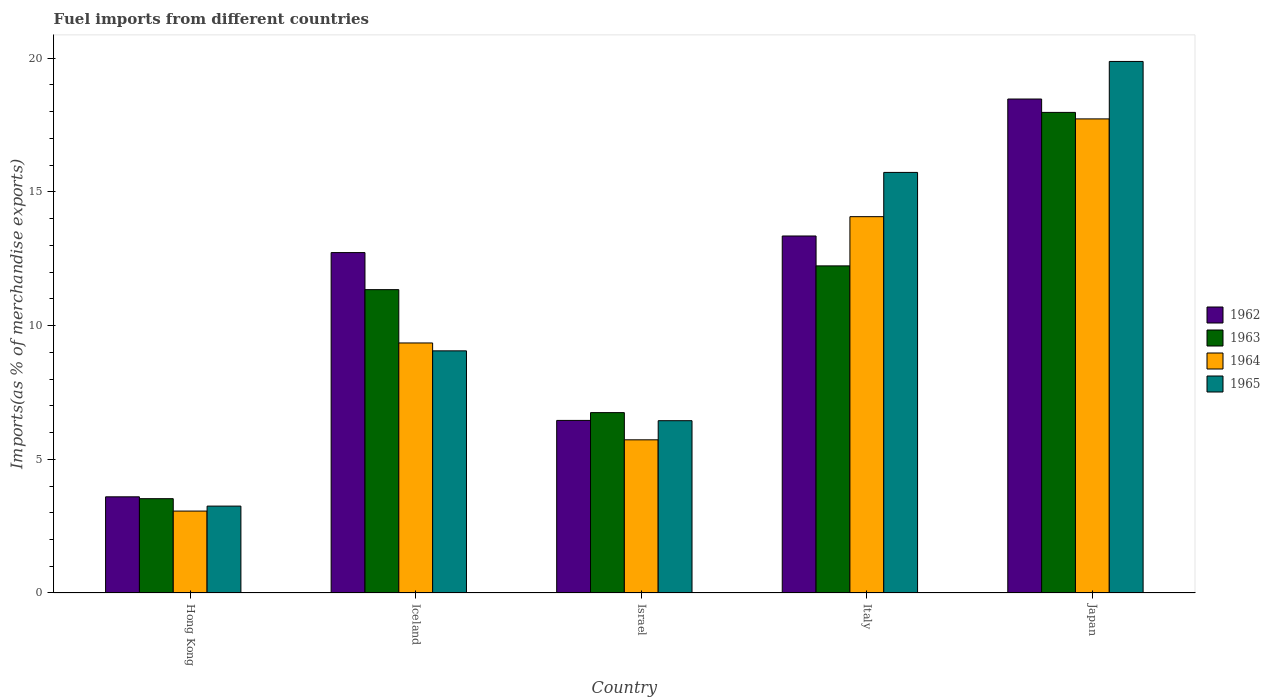How many different coloured bars are there?
Offer a very short reply. 4. How many bars are there on the 2nd tick from the left?
Provide a short and direct response. 4. How many bars are there on the 4th tick from the right?
Offer a terse response. 4. What is the label of the 1st group of bars from the left?
Make the answer very short. Hong Kong. In how many cases, is the number of bars for a given country not equal to the number of legend labels?
Provide a succinct answer. 0. What is the percentage of imports to different countries in 1963 in Japan?
Make the answer very short. 17.97. Across all countries, what is the maximum percentage of imports to different countries in 1964?
Your response must be concise. 17.73. Across all countries, what is the minimum percentage of imports to different countries in 1962?
Offer a terse response. 3.6. In which country was the percentage of imports to different countries in 1962 maximum?
Ensure brevity in your answer.  Japan. In which country was the percentage of imports to different countries in 1964 minimum?
Keep it short and to the point. Hong Kong. What is the total percentage of imports to different countries in 1963 in the graph?
Offer a very short reply. 51.83. What is the difference between the percentage of imports to different countries in 1964 in Hong Kong and that in Iceland?
Make the answer very short. -6.29. What is the difference between the percentage of imports to different countries in 1962 in Israel and the percentage of imports to different countries in 1965 in Hong Kong?
Keep it short and to the point. 3.2. What is the average percentage of imports to different countries in 1963 per country?
Keep it short and to the point. 10.37. What is the difference between the percentage of imports to different countries of/in 1965 and percentage of imports to different countries of/in 1962 in Japan?
Make the answer very short. 1.41. In how many countries, is the percentage of imports to different countries in 1964 greater than 8 %?
Provide a succinct answer. 3. What is the ratio of the percentage of imports to different countries in 1963 in Iceland to that in Japan?
Ensure brevity in your answer.  0.63. Is the percentage of imports to different countries in 1965 in Iceland less than that in Japan?
Keep it short and to the point. Yes. Is the difference between the percentage of imports to different countries in 1965 in Israel and Japan greater than the difference between the percentage of imports to different countries in 1962 in Israel and Japan?
Offer a very short reply. No. What is the difference between the highest and the second highest percentage of imports to different countries in 1965?
Your answer should be compact. -10.82. What is the difference between the highest and the lowest percentage of imports to different countries in 1962?
Your answer should be very brief. 14.88. Is it the case that in every country, the sum of the percentage of imports to different countries in 1965 and percentage of imports to different countries in 1963 is greater than the sum of percentage of imports to different countries in 1962 and percentage of imports to different countries in 1964?
Keep it short and to the point. No. What does the 3rd bar from the left in Italy represents?
Provide a succinct answer. 1964. What does the 2nd bar from the right in Hong Kong represents?
Ensure brevity in your answer.  1964. Is it the case that in every country, the sum of the percentage of imports to different countries in 1964 and percentage of imports to different countries in 1963 is greater than the percentage of imports to different countries in 1962?
Provide a short and direct response. Yes. How many bars are there?
Your answer should be very brief. 20. Are all the bars in the graph horizontal?
Offer a very short reply. No. How many countries are there in the graph?
Your answer should be very brief. 5. What is the difference between two consecutive major ticks on the Y-axis?
Give a very brief answer. 5. Does the graph contain any zero values?
Offer a terse response. No. Does the graph contain grids?
Offer a very short reply. No. How many legend labels are there?
Make the answer very short. 4. How are the legend labels stacked?
Provide a succinct answer. Vertical. What is the title of the graph?
Provide a succinct answer. Fuel imports from different countries. What is the label or title of the Y-axis?
Give a very brief answer. Imports(as % of merchandise exports). What is the Imports(as % of merchandise exports) of 1962 in Hong Kong?
Your answer should be compact. 3.6. What is the Imports(as % of merchandise exports) in 1963 in Hong Kong?
Ensure brevity in your answer.  3.53. What is the Imports(as % of merchandise exports) in 1964 in Hong Kong?
Your answer should be compact. 3.06. What is the Imports(as % of merchandise exports) in 1965 in Hong Kong?
Your response must be concise. 3.25. What is the Imports(as % of merchandise exports) in 1962 in Iceland?
Offer a very short reply. 12.73. What is the Imports(as % of merchandise exports) in 1963 in Iceland?
Offer a very short reply. 11.35. What is the Imports(as % of merchandise exports) in 1964 in Iceland?
Provide a succinct answer. 9.35. What is the Imports(as % of merchandise exports) of 1965 in Iceland?
Your response must be concise. 9.06. What is the Imports(as % of merchandise exports) of 1962 in Israel?
Your response must be concise. 6.45. What is the Imports(as % of merchandise exports) of 1963 in Israel?
Give a very brief answer. 6.75. What is the Imports(as % of merchandise exports) in 1964 in Israel?
Make the answer very short. 5.73. What is the Imports(as % of merchandise exports) in 1965 in Israel?
Your response must be concise. 6.44. What is the Imports(as % of merchandise exports) in 1962 in Italy?
Your answer should be compact. 13.35. What is the Imports(as % of merchandise exports) of 1963 in Italy?
Your answer should be compact. 12.23. What is the Imports(as % of merchandise exports) in 1964 in Italy?
Give a very brief answer. 14.07. What is the Imports(as % of merchandise exports) in 1965 in Italy?
Provide a short and direct response. 15.73. What is the Imports(as % of merchandise exports) of 1962 in Japan?
Keep it short and to the point. 18.47. What is the Imports(as % of merchandise exports) in 1963 in Japan?
Make the answer very short. 17.97. What is the Imports(as % of merchandise exports) of 1964 in Japan?
Ensure brevity in your answer.  17.73. What is the Imports(as % of merchandise exports) in 1965 in Japan?
Make the answer very short. 19.88. Across all countries, what is the maximum Imports(as % of merchandise exports) of 1962?
Ensure brevity in your answer.  18.47. Across all countries, what is the maximum Imports(as % of merchandise exports) of 1963?
Ensure brevity in your answer.  17.97. Across all countries, what is the maximum Imports(as % of merchandise exports) in 1964?
Ensure brevity in your answer.  17.73. Across all countries, what is the maximum Imports(as % of merchandise exports) in 1965?
Your answer should be compact. 19.88. Across all countries, what is the minimum Imports(as % of merchandise exports) of 1962?
Your response must be concise. 3.6. Across all countries, what is the minimum Imports(as % of merchandise exports) of 1963?
Keep it short and to the point. 3.53. Across all countries, what is the minimum Imports(as % of merchandise exports) of 1964?
Offer a terse response. 3.06. Across all countries, what is the minimum Imports(as % of merchandise exports) in 1965?
Offer a very short reply. 3.25. What is the total Imports(as % of merchandise exports) in 1962 in the graph?
Offer a very short reply. 54.61. What is the total Imports(as % of merchandise exports) of 1963 in the graph?
Keep it short and to the point. 51.83. What is the total Imports(as % of merchandise exports) in 1964 in the graph?
Make the answer very short. 49.95. What is the total Imports(as % of merchandise exports) of 1965 in the graph?
Provide a short and direct response. 54.36. What is the difference between the Imports(as % of merchandise exports) of 1962 in Hong Kong and that in Iceland?
Offer a very short reply. -9.13. What is the difference between the Imports(as % of merchandise exports) of 1963 in Hong Kong and that in Iceland?
Provide a succinct answer. -7.82. What is the difference between the Imports(as % of merchandise exports) in 1964 in Hong Kong and that in Iceland?
Your answer should be compact. -6.29. What is the difference between the Imports(as % of merchandise exports) in 1965 in Hong Kong and that in Iceland?
Keep it short and to the point. -5.81. What is the difference between the Imports(as % of merchandise exports) of 1962 in Hong Kong and that in Israel?
Make the answer very short. -2.86. What is the difference between the Imports(as % of merchandise exports) in 1963 in Hong Kong and that in Israel?
Your answer should be very brief. -3.22. What is the difference between the Imports(as % of merchandise exports) of 1964 in Hong Kong and that in Israel?
Provide a short and direct response. -2.66. What is the difference between the Imports(as % of merchandise exports) of 1965 in Hong Kong and that in Israel?
Your response must be concise. -3.19. What is the difference between the Imports(as % of merchandise exports) of 1962 in Hong Kong and that in Italy?
Provide a succinct answer. -9.76. What is the difference between the Imports(as % of merchandise exports) in 1963 in Hong Kong and that in Italy?
Keep it short and to the point. -8.71. What is the difference between the Imports(as % of merchandise exports) of 1964 in Hong Kong and that in Italy?
Your response must be concise. -11.01. What is the difference between the Imports(as % of merchandise exports) in 1965 in Hong Kong and that in Italy?
Offer a very short reply. -12.48. What is the difference between the Imports(as % of merchandise exports) in 1962 in Hong Kong and that in Japan?
Offer a very short reply. -14.88. What is the difference between the Imports(as % of merchandise exports) in 1963 in Hong Kong and that in Japan?
Provide a succinct answer. -14.45. What is the difference between the Imports(as % of merchandise exports) in 1964 in Hong Kong and that in Japan?
Ensure brevity in your answer.  -14.67. What is the difference between the Imports(as % of merchandise exports) of 1965 in Hong Kong and that in Japan?
Provide a succinct answer. -16.63. What is the difference between the Imports(as % of merchandise exports) of 1962 in Iceland and that in Israel?
Your response must be concise. 6.28. What is the difference between the Imports(as % of merchandise exports) in 1963 in Iceland and that in Israel?
Your answer should be compact. 4.6. What is the difference between the Imports(as % of merchandise exports) in 1964 in Iceland and that in Israel?
Provide a succinct answer. 3.62. What is the difference between the Imports(as % of merchandise exports) of 1965 in Iceland and that in Israel?
Offer a very short reply. 2.61. What is the difference between the Imports(as % of merchandise exports) in 1962 in Iceland and that in Italy?
Your answer should be compact. -0.62. What is the difference between the Imports(as % of merchandise exports) in 1963 in Iceland and that in Italy?
Offer a very short reply. -0.89. What is the difference between the Imports(as % of merchandise exports) of 1964 in Iceland and that in Italy?
Provide a succinct answer. -4.72. What is the difference between the Imports(as % of merchandise exports) in 1965 in Iceland and that in Italy?
Offer a very short reply. -6.67. What is the difference between the Imports(as % of merchandise exports) of 1962 in Iceland and that in Japan?
Offer a terse response. -5.74. What is the difference between the Imports(as % of merchandise exports) of 1963 in Iceland and that in Japan?
Ensure brevity in your answer.  -6.63. What is the difference between the Imports(as % of merchandise exports) in 1964 in Iceland and that in Japan?
Ensure brevity in your answer.  -8.38. What is the difference between the Imports(as % of merchandise exports) in 1965 in Iceland and that in Japan?
Offer a very short reply. -10.82. What is the difference between the Imports(as % of merchandise exports) in 1962 in Israel and that in Italy?
Keep it short and to the point. -6.9. What is the difference between the Imports(as % of merchandise exports) in 1963 in Israel and that in Italy?
Your answer should be compact. -5.49. What is the difference between the Imports(as % of merchandise exports) in 1964 in Israel and that in Italy?
Keep it short and to the point. -8.35. What is the difference between the Imports(as % of merchandise exports) in 1965 in Israel and that in Italy?
Your answer should be very brief. -9.29. What is the difference between the Imports(as % of merchandise exports) of 1962 in Israel and that in Japan?
Offer a terse response. -12.02. What is the difference between the Imports(as % of merchandise exports) of 1963 in Israel and that in Japan?
Offer a very short reply. -11.23. What is the difference between the Imports(as % of merchandise exports) of 1964 in Israel and that in Japan?
Your answer should be very brief. -12. What is the difference between the Imports(as % of merchandise exports) of 1965 in Israel and that in Japan?
Offer a very short reply. -13.44. What is the difference between the Imports(as % of merchandise exports) of 1962 in Italy and that in Japan?
Give a very brief answer. -5.12. What is the difference between the Imports(as % of merchandise exports) of 1963 in Italy and that in Japan?
Give a very brief answer. -5.74. What is the difference between the Imports(as % of merchandise exports) of 1964 in Italy and that in Japan?
Your answer should be compact. -3.66. What is the difference between the Imports(as % of merchandise exports) in 1965 in Italy and that in Japan?
Your response must be concise. -4.15. What is the difference between the Imports(as % of merchandise exports) of 1962 in Hong Kong and the Imports(as % of merchandise exports) of 1963 in Iceland?
Offer a terse response. -7.75. What is the difference between the Imports(as % of merchandise exports) of 1962 in Hong Kong and the Imports(as % of merchandise exports) of 1964 in Iceland?
Provide a short and direct response. -5.75. What is the difference between the Imports(as % of merchandise exports) of 1962 in Hong Kong and the Imports(as % of merchandise exports) of 1965 in Iceland?
Your answer should be compact. -5.46. What is the difference between the Imports(as % of merchandise exports) of 1963 in Hong Kong and the Imports(as % of merchandise exports) of 1964 in Iceland?
Ensure brevity in your answer.  -5.82. What is the difference between the Imports(as % of merchandise exports) in 1963 in Hong Kong and the Imports(as % of merchandise exports) in 1965 in Iceland?
Give a very brief answer. -5.53. What is the difference between the Imports(as % of merchandise exports) in 1964 in Hong Kong and the Imports(as % of merchandise exports) in 1965 in Iceland?
Your answer should be very brief. -5.99. What is the difference between the Imports(as % of merchandise exports) of 1962 in Hong Kong and the Imports(as % of merchandise exports) of 1963 in Israel?
Give a very brief answer. -3.15. What is the difference between the Imports(as % of merchandise exports) of 1962 in Hong Kong and the Imports(as % of merchandise exports) of 1964 in Israel?
Offer a terse response. -2.13. What is the difference between the Imports(as % of merchandise exports) in 1962 in Hong Kong and the Imports(as % of merchandise exports) in 1965 in Israel?
Ensure brevity in your answer.  -2.85. What is the difference between the Imports(as % of merchandise exports) of 1963 in Hong Kong and the Imports(as % of merchandise exports) of 1964 in Israel?
Your answer should be compact. -2.2. What is the difference between the Imports(as % of merchandise exports) in 1963 in Hong Kong and the Imports(as % of merchandise exports) in 1965 in Israel?
Your answer should be very brief. -2.92. What is the difference between the Imports(as % of merchandise exports) of 1964 in Hong Kong and the Imports(as % of merchandise exports) of 1965 in Israel?
Keep it short and to the point. -3.38. What is the difference between the Imports(as % of merchandise exports) in 1962 in Hong Kong and the Imports(as % of merchandise exports) in 1963 in Italy?
Give a very brief answer. -8.64. What is the difference between the Imports(as % of merchandise exports) of 1962 in Hong Kong and the Imports(as % of merchandise exports) of 1964 in Italy?
Provide a succinct answer. -10.48. What is the difference between the Imports(as % of merchandise exports) in 1962 in Hong Kong and the Imports(as % of merchandise exports) in 1965 in Italy?
Your answer should be very brief. -12.13. What is the difference between the Imports(as % of merchandise exports) in 1963 in Hong Kong and the Imports(as % of merchandise exports) in 1964 in Italy?
Provide a succinct answer. -10.55. What is the difference between the Imports(as % of merchandise exports) of 1963 in Hong Kong and the Imports(as % of merchandise exports) of 1965 in Italy?
Provide a succinct answer. -12.2. What is the difference between the Imports(as % of merchandise exports) in 1964 in Hong Kong and the Imports(as % of merchandise exports) in 1965 in Italy?
Offer a terse response. -12.67. What is the difference between the Imports(as % of merchandise exports) in 1962 in Hong Kong and the Imports(as % of merchandise exports) in 1963 in Japan?
Make the answer very short. -14.38. What is the difference between the Imports(as % of merchandise exports) in 1962 in Hong Kong and the Imports(as % of merchandise exports) in 1964 in Japan?
Provide a succinct answer. -14.13. What is the difference between the Imports(as % of merchandise exports) in 1962 in Hong Kong and the Imports(as % of merchandise exports) in 1965 in Japan?
Your answer should be very brief. -16.28. What is the difference between the Imports(as % of merchandise exports) of 1963 in Hong Kong and the Imports(as % of merchandise exports) of 1964 in Japan?
Provide a succinct answer. -14.2. What is the difference between the Imports(as % of merchandise exports) in 1963 in Hong Kong and the Imports(as % of merchandise exports) in 1965 in Japan?
Make the answer very short. -16.35. What is the difference between the Imports(as % of merchandise exports) in 1964 in Hong Kong and the Imports(as % of merchandise exports) in 1965 in Japan?
Your answer should be compact. -16.82. What is the difference between the Imports(as % of merchandise exports) of 1962 in Iceland and the Imports(as % of merchandise exports) of 1963 in Israel?
Provide a succinct answer. 5.99. What is the difference between the Imports(as % of merchandise exports) in 1962 in Iceland and the Imports(as % of merchandise exports) in 1964 in Israel?
Provide a short and direct response. 7. What is the difference between the Imports(as % of merchandise exports) in 1962 in Iceland and the Imports(as % of merchandise exports) in 1965 in Israel?
Offer a terse response. 6.29. What is the difference between the Imports(as % of merchandise exports) of 1963 in Iceland and the Imports(as % of merchandise exports) of 1964 in Israel?
Offer a very short reply. 5.62. What is the difference between the Imports(as % of merchandise exports) of 1963 in Iceland and the Imports(as % of merchandise exports) of 1965 in Israel?
Provide a succinct answer. 4.9. What is the difference between the Imports(as % of merchandise exports) in 1964 in Iceland and the Imports(as % of merchandise exports) in 1965 in Israel?
Offer a very short reply. 2.91. What is the difference between the Imports(as % of merchandise exports) of 1962 in Iceland and the Imports(as % of merchandise exports) of 1963 in Italy?
Your answer should be compact. 0.5. What is the difference between the Imports(as % of merchandise exports) of 1962 in Iceland and the Imports(as % of merchandise exports) of 1964 in Italy?
Your answer should be compact. -1.34. What is the difference between the Imports(as % of merchandise exports) of 1962 in Iceland and the Imports(as % of merchandise exports) of 1965 in Italy?
Give a very brief answer. -3. What is the difference between the Imports(as % of merchandise exports) of 1963 in Iceland and the Imports(as % of merchandise exports) of 1964 in Italy?
Your response must be concise. -2.73. What is the difference between the Imports(as % of merchandise exports) of 1963 in Iceland and the Imports(as % of merchandise exports) of 1965 in Italy?
Your response must be concise. -4.38. What is the difference between the Imports(as % of merchandise exports) in 1964 in Iceland and the Imports(as % of merchandise exports) in 1965 in Italy?
Offer a terse response. -6.38. What is the difference between the Imports(as % of merchandise exports) of 1962 in Iceland and the Imports(as % of merchandise exports) of 1963 in Japan?
Offer a very short reply. -5.24. What is the difference between the Imports(as % of merchandise exports) in 1962 in Iceland and the Imports(as % of merchandise exports) in 1964 in Japan?
Make the answer very short. -5. What is the difference between the Imports(as % of merchandise exports) in 1962 in Iceland and the Imports(as % of merchandise exports) in 1965 in Japan?
Provide a succinct answer. -7.15. What is the difference between the Imports(as % of merchandise exports) of 1963 in Iceland and the Imports(as % of merchandise exports) of 1964 in Japan?
Ensure brevity in your answer.  -6.39. What is the difference between the Imports(as % of merchandise exports) of 1963 in Iceland and the Imports(as % of merchandise exports) of 1965 in Japan?
Your response must be concise. -8.53. What is the difference between the Imports(as % of merchandise exports) of 1964 in Iceland and the Imports(as % of merchandise exports) of 1965 in Japan?
Ensure brevity in your answer.  -10.53. What is the difference between the Imports(as % of merchandise exports) in 1962 in Israel and the Imports(as % of merchandise exports) in 1963 in Italy?
Make the answer very short. -5.78. What is the difference between the Imports(as % of merchandise exports) of 1962 in Israel and the Imports(as % of merchandise exports) of 1964 in Italy?
Provide a succinct answer. -7.62. What is the difference between the Imports(as % of merchandise exports) in 1962 in Israel and the Imports(as % of merchandise exports) in 1965 in Italy?
Your answer should be compact. -9.28. What is the difference between the Imports(as % of merchandise exports) in 1963 in Israel and the Imports(as % of merchandise exports) in 1964 in Italy?
Make the answer very short. -7.33. What is the difference between the Imports(as % of merchandise exports) of 1963 in Israel and the Imports(as % of merchandise exports) of 1965 in Italy?
Provide a short and direct response. -8.98. What is the difference between the Imports(as % of merchandise exports) in 1964 in Israel and the Imports(as % of merchandise exports) in 1965 in Italy?
Offer a very short reply. -10. What is the difference between the Imports(as % of merchandise exports) of 1962 in Israel and the Imports(as % of merchandise exports) of 1963 in Japan?
Make the answer very short. -11.52. What is the difference between the Imports(as % of merchandise exports) in 1962 in Israel and the Imports(as % of merchandise exports) in 1964 in Japan?
Provide a succinct answer. -11.28. What is the difference between the Imports(as % of merchandise exports) of 1962 in Israel and the Imports(as % of merchandise exports) of 1965 in Japan?
Your answer should be very brief. -13.43. What is the difference between the Imports(as % of merchandise exports) of 1963 in Israel and the Imports(as % of merchandise exports) of 1964 in Japan?
Keep it short and to the point. -10.99. What is the difference between the Imports(as % of merchandise exports) in 1963 in Israel and the Imports(as % of merchandise exports) in 1965 in Japan?
Make the answer very short. -13.13. What is the difference between the Imports(as % of merchandise exports) in 1964 in Israel and the Imports(as % of merchandise exports) in 1965 in Japan?
Provide a short and direct response. -14.15. What is the difference between the Imports(as % of merchandise exports) in 1962 in Italy and the Imports(as % of merchandise exports) in 1963 in Japan?
Your answer should be compact. -4.62. What is the difference between the Imports(as % of merchandise exports) of 1962 in Italy and the Imports(as % of merchandise exports) of 1964 in Japan?
Keep it short and to the point. -4.38. What is the difference between the Imports(as % of merchandise exports) in 1962 in Italy and the Imports(as % of merchandise exports) in 1965 in Japan?
Provide a short and direct response. -6.53. What is the difference between the Imports(as % of merchandise exports) of 1963 in Italy and the Imports(as % of merchandise exports) of 1964 in Japan?
Your response must be concise. -5.5. What is the difference between the Imports(as % of merchandise exports) in 1963 in Italy and the Imports(as % of merchandise exports) in 1965 in Japan?
Keep it short and to the point. -7.65. What is the difference between the Imports(as % of merchandise exports) in 1964 in Italy and the Imports(as % of merchandise exports) in 1965 in Japan?
Provide a short and direct response. -5.8. What is the average Imports(as % of merchandise exports) in 1962 per country?
Your answer should be very brief. 10.92. What is the average Imports(as % of merchandise exports) of 1963 per country?
Offer a terse response. 10.37. What is the average Imports(as % of merchandise exports) of 1964 per country?
Offer a very short reply. 9.99. What is the average Imports(as % of merchandise exports) of 1965 per country?
Make the answer very short. 10.87. What is the difference between the Imports(as % of merchandise exports) in 1962 and Imports(as % of merchandise exports) in 1963 in Hong Kong?
Provide a succinct answer. 0.07. What is the difference between the Imports(as % of merchandise exports) of 1962 and Imports(as % of merchandise exports) of 1964 in Hong Kong?
Offer a very short reply. 0.53. What is the difference between the Imports(as % of merchandise exports) in 1962 and Imports(as % of merchandise exports) in 1965 in Hong Kong?
Your answer should be compact. 0.35. What is the difference between the Imports(as % of merchandise exports) in 1963 and Imports(as % of merchandise exports) in 1964 in Hong Kong?
Your answer should be very brief. 0.46. What is the difference between the Imports(as % of merchandise exports) in 1963 and Imports(as % of merchandise exports) in 1965 in Hong Kong?
Ensure brevity in your answer.  0.28. What is the difference between the Imports(as % of merchandise exports) of 1964 and Imports(as % of merchandise exports) of 1965 in Hong Kong?
Make the answer very short. -0.19. What is the difference between the Imports(as % of merchandise exports) in 1962 and Imports(as % of merchandise exports) in 1963 in Iceland?
Your response must be concise. 1.39. What is the difference between the Imports(as % of merchandise exports) in 1962 and Imports(as % of merchandise exports) in 1964 in Iceland?
Provide a succinct answer. 3.38. What is the difference between the Imports(as % of merchandise exports) in 1962 and Imports(as % of merchandise exports) in 1965 in Iceland?
Keep it short and to the point. 3.67. What is the difference between the Imports(as % of merchandise exports) in 1963 and Imports(as % of merchandise exports) in 1964 in Iceland?
Give a very brief answer. 1.99. What is the difference between the Imports(as % of merchandise exports) of 1963 and Imports(as % of merchandise exports) of 1965 in Iceland?
Provide a short and direct response. 2.29. What is the difference between the Imports(as % of merchandise exports) in 1964 and Imports(as % of merchandise exports) in 1965 in Iceland?
Your response must be concise. 0.29. What is the difference between the Imports(as % of merchandise exports) of 1962 and Imports(as % of merchandise exports) of 1963 in Israel?
Offer a very short reply. -0.29. What is the difference between the Imports(as % of merchandise exports) of 1962 and Imports(as % of merchandise exports) of 1964 in Israel?
Your answer should be compact. 0.73. What is the difference between the Imports(as % of merchandise exports) of 1962 and Imports(as % of merchandise exports) of 1965 in Israel?
Your answer should be very brief. 0.01. What is the difference between the Imports(as % of merchandise exports) of 1963 and Imports(as % of merchandise exports) of 1964 in Israel?
Your answer should be very brief. 1.02. What is the difference between the Imports(as % of merchandise exports) in 1963 and Imports(as % of merchandise exports) in 1965 in Israel?
Provide a short and direct response. 0.3. What is the difference between the Imports(as % of merchandise exports) of 1964 and Imports(as % of merchandise exports) of 1965 in Israel?
Your response must be concise. -0.72. What is the difference between the Imports(as % of merchandise exports) of 1962 and Imports(as % of merchandise exports) of 1963 in Italy?
Your response must be concise. 1.12. What is the difference between the Imports(as % of merchandise exports) of 1962 and Imports(as % of merchandise exports) of 1964 in Italy?
Keep it short and to the point. -0.72. What is the difference between the Imports(as % of merchandise exports) in 1962 and Imports(as % of merchandise exports) in 1965 in Italy?
Provide a succinct answer. -2.38. What is the difference between the Imports(as % of merchandise exports) of 1963 and Imports(as % of merchandise exports) of 1964 in Italy?
Provide a short and direct response. -1.84. What is the difference between the Imports(as % of merchandise exports) in 1963 and Imports(as % of merchandise exports) in 1965 in Italy?
Offer a very short reply. -3.5. What is the difference between the Imports(as % of merchandise exports) of 1964 and Imports(as % of merchandise exports) of 1965 in Italy?
Your response must be concise. -1.65. What is the difference between the Imports(as % of merchandise exports) of 1962 and Imports(as % of merchandise exports) of 1964 in Japan?
Your answer should be compact. 0.74. What is the difference between the Imports(as % of merchandise exports) in 1962 and Imports(as % of merchandise exports) in 1965 in Japan?
Your answer should be compact. -1.41. What is the difference between the Imports(as % of merchandise exports) in 1963 and Imports(as % of merchandise exports) in 1964 in Japan?
Your response must be concise. 0.24. What is the difference between the Imports(as % of merchandise exports) of 1963 and Imports(as % of merchandise exports) of 1965 in Japan?
Your response must be concise. -1.91. What is the difference between the Imports(as % of merchandise exports) in 1964 and Imports(as % of merchandise exports) in 1965 in Japan?
Offer a terse response. -2.15. What is the ratio of the Imports(as % of merchandise exports) of 1962 in Hong Kong to that in Iceland?
Make the answer very short. 0.28. What is the ratio of the Imports(as % of merchandise exports) of 1963 in Hong Kong to that in Iceland?
Provide a succinct answer. 0.31. What is the ratio of the Imports(as % of merchandise exports) of 1964 in Hong Kong to that in Iceland?
Provide a succinct answer. 0.33. What is the ratio of the Imports(as % of merchandise exports) in 1965 in Hong Kong to that in Iceland?
Offer a very short reply. 0.36. What is the ratio of the Imports(as % of merchandise exports) in 1962 in Hong Kong to that in Israel?
Your answer should be very brief. 0.56. What is the ratio of the Imports(as % of merchandise exports) in 1963 in Hong Kong to that in Israel?
Your answer should be very brief. 0.52. What is the ratio of the Imports(as % of merchandise exports) of 1964 in Hong Kong to that in Israel?
Keep it short and to the point. 0.53. What is the ratio of the Imports(as % of merchandise exports) of 1965 in Hong Kong to that in Israel?
Provide a short and direct response. 0.5. What is the ratio of the Imports(as % of merchandise exports) of 1962 in Hong Kong to that in Italy?
Provide a succinct answer. 0.27. What is the ratio of the Imports(as % of merchandise exports) in 1963 in Hong Kong to that in Italy?
Offer a terse response. 0.29. What is the ratio of the Imports(as % of merchandise exports) of 1964 in Hong Kong to that in Italy?
Your answer should be very brief. 0.22. What is the ratio of the Imports(as % of merchandise exports) in 1965 in Hong Kong to that in Italy?
Ensure brevity in your answer.  0.21. What is the ratio of the Imports(as % of merchandise exports) in 1962 in Hong Kong to that in Japan?
Your answer should be very brief. 0.19. What is the ratio of the Imports(as % of merchandise exports) of 1963 in Hong Kong to that in Japan?
Your answer should be compact. 0.2. What is the ratio of the Imports(as % of merchandise exports) of 1964 in Hong Kong to that in Japan?
Make the answer very short. 0.17. What is the ratio of the Imports(as % of merchandise exports) of 1965 in Hong Kong to that in Japan?
Keep it short and to the point. 0.16. What is the ratio of the Imports(as % of merchandise exports) in 1962 in Iceland to that in Israel?
Ensure brevity in your answer.  1.97. What is the ratio of the Imports(as % of merchandise exports) of 1963 in Iceland to that in Israel?
Offer a very short reply. 1.68. What is the ratio of the Imports(as % of merchandise exports) of 1964 in Iceland to that in Israel?
Provide a succinct answer. 1.63. What is the ratio of the Imports(as % of merchandise exports) of 1965 in Iceland to that in Israel?
Your answer should be very brief. 1.41. What is the ratio of the Imports(as % of merchandise exports) in 1962 in Iceland to that in Italy?
Your answer should be very brief. 0.95. What is the ratio of the Imports(as % of merchandise exports) of 1963 in Iceland to that in Italy?
Your answer should be compact. 0.93. What is the ratio of the Imports(as % of merchandise exports) of 1964 in Iceland to that in Italy?
Your answer should be compact. 0.66. What is the ratio of the Imports(as % of merchandise exports) of 1965 in Iceland to that in Italy?
Ensure brevity in your answer.  0.58. What is the ratio of the Imports(as % of merchandise exports) of 1962 in Iceland to that in Japan?
Provide a short and direct response. 0.69. What is the ratio of the Imports(as % of merchandise exports) in 1963 in Iceland to that in Japan?
Your answer should be very brief. 0.63. What is the ratio of the Imports(as % of merchandise exports) of 1964 in Iceland to that in Japan?
Offer a terse response. 0.53. What is the ratio of the Imports(as % of merchandise exports) of 1965 in Iceland to that in Japan?
Your response must be concise. 0.46. What is the ratio of the Imports(as % of merchandise exports) of 1962 in Israel to that in Italy?
Your response must be concise. 0.48. What is the ratio of the Imports(as % of merchandise exports) in 1963 in Israel to that in Italy?
Your response must be concise. 0.55. What is the ratio of the Imports(as % of merchandise exports) in 1964 in Israel to that in Italy?
Provide a short and direct response. 0.41. What is the ratio of the Imports(as % of merchandise exports) of 1965 in Israel to that in Italy?
Your response must be concise. 0.41. What is the ratio of the Imports(as % of merchandise exports) of 1962 in Israel to that in Japan?
Ensure brevity in your answer.  0.35. What is the ratio of the Imports(as % of merchandise exports) of 1963 in Israel to that in Japan?
Provide a short and direct response. 0.38. What is the ratio of the Imports(as % of merchandise exports) of 1964 in Israel to that in Japan?
Make the answer very short. 0.32. What is the ratio of the Imports(as % of merchandise exports) in 1965 in Israel to that in Japan?
Offer a terse response. 0.32. What is the ratio of the Imports(as % of merchandise exports) of 1962 in Italy to that in Japan?
Provide a short and direct response. 0.72. What is the ratio of the Imports(as % of merchandise exports) in 1963 in Italy to that in Japan?
Provide a succinct answer. 0.68. What is the ratio of the Imports(as % of merchandise exports) of 1964 in Italy to that in Japan?
Your answer should be compact. 0.79. What is the ratio of the Imports(as % of merchandise exports) in 1965 in Italy to that in Japan?
Your answer should be very brief. 0.79. What is the difference between the highest and the second highest Imports(as % of merchandise exports) of 1962?
Make the answer very short. 5.12. What is the difference between the highest and the second highest Imports(as % of merchandise exports) in 1963?
Provide a short and direct response. 5.74. What is the difference between the highest and the second highest Imports(as % of merchandise exports) in 1964?
Your answer should be very brief. 3.66. What is the difference between the highest and the second highest Imports(as % of merchandise exports) in 1965?
Offer a terse response. 4.15. What is the difference between the highest and the lowest Imports(as % of merchandise exports) in 1962?
Your answer should be very brief. 14.88. What is the difference between the highest and the lowest Imports(as % of merchandise exports) of 1963?
Provide a succinct answer. 14.45. What is the difference between the highest and the lowest Imports(as % of merchandise exports) in 1964?
Provide a succinct answer. 14.67. What is the difference between the highest and the lowest Imports(as % of merchandise exports) of 1965?
Keep it short and to the point. 16.63. 